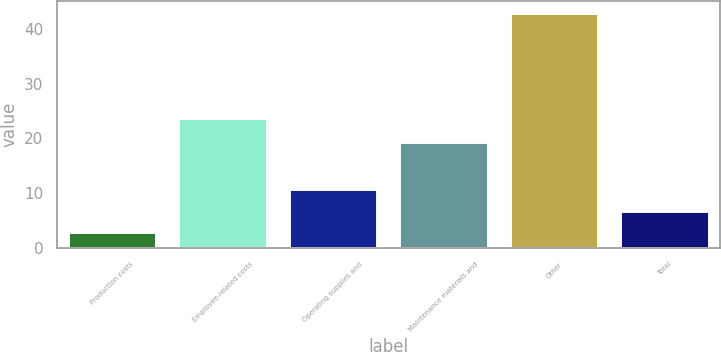<chart> <loc_0><loc_0><loc_500><loc_500><bar_chart><fcel>Production costs<fcel>Employee-related costs<fcel>Operating supplies and<fcel>Maintenance materials and<fcel>Other<fcel>Total<nl><fcel>2.8<fcel>23.7<fcel>10.82<fcel>19.3<fcel>42.9<fcel>6.81<nl></chart> 